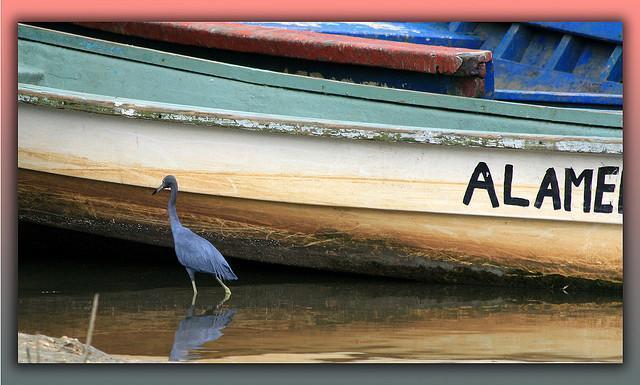How many birds can you see?
Give a very brief answer. 1. How many boats can you see?
Give a very brief answer. 1. How many empty vases are in the image?
Give a very brief answer. 0. 